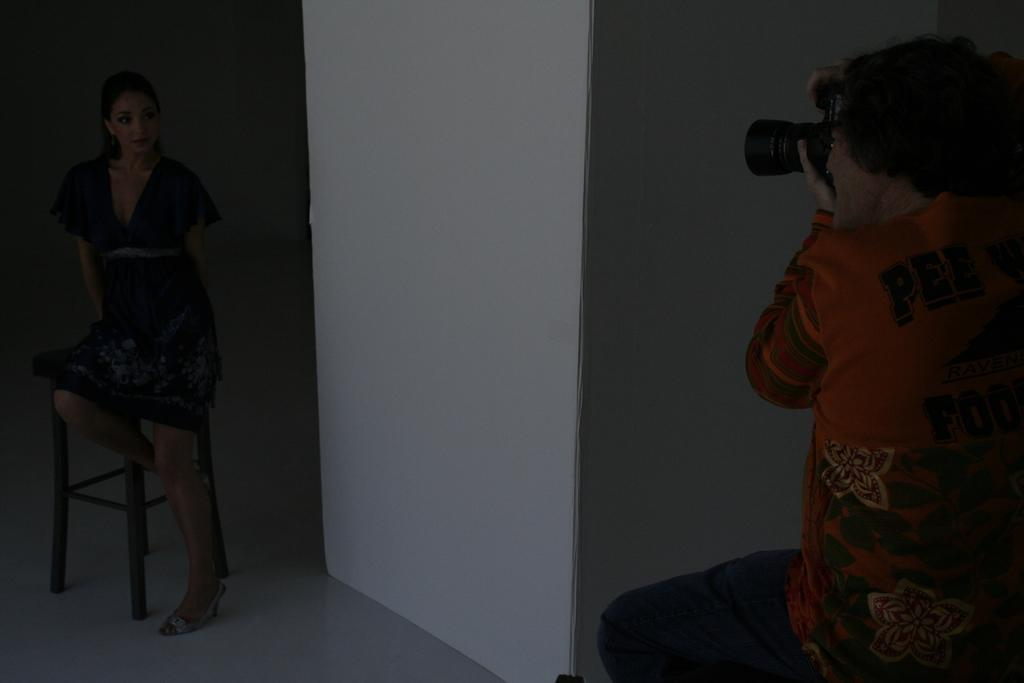Who is the main subject on the left side of the image? There is a lady on the left side of the image. What is the lady standing on? The lady is standing on a stool on the left side of the image. Who is the other person in the image? There is a man in the image, and he is on the right side. What is the man holding in his hands? The man is holding a camera in his hands. What can be seen in the center of the image? There is a wall in the center of the image. What type of pipe is visible in the image? There is no pipe present in the image. Can you tell me how the actor is performing in the image? There is no actor or performance depicted in the image; it features a lady and a man in separate positions. 